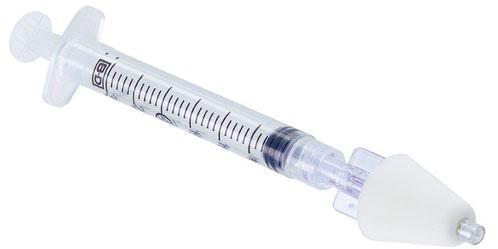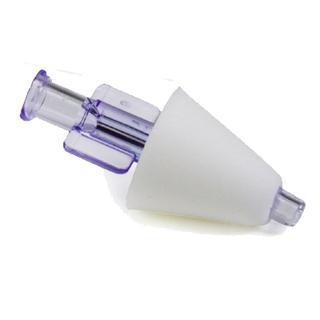The first image is the image on the left, the second image is the image on the right. Assess this claim about the two images: "The image on the right contains a cone.". Correct or not? Answer yes or no. Yes. 